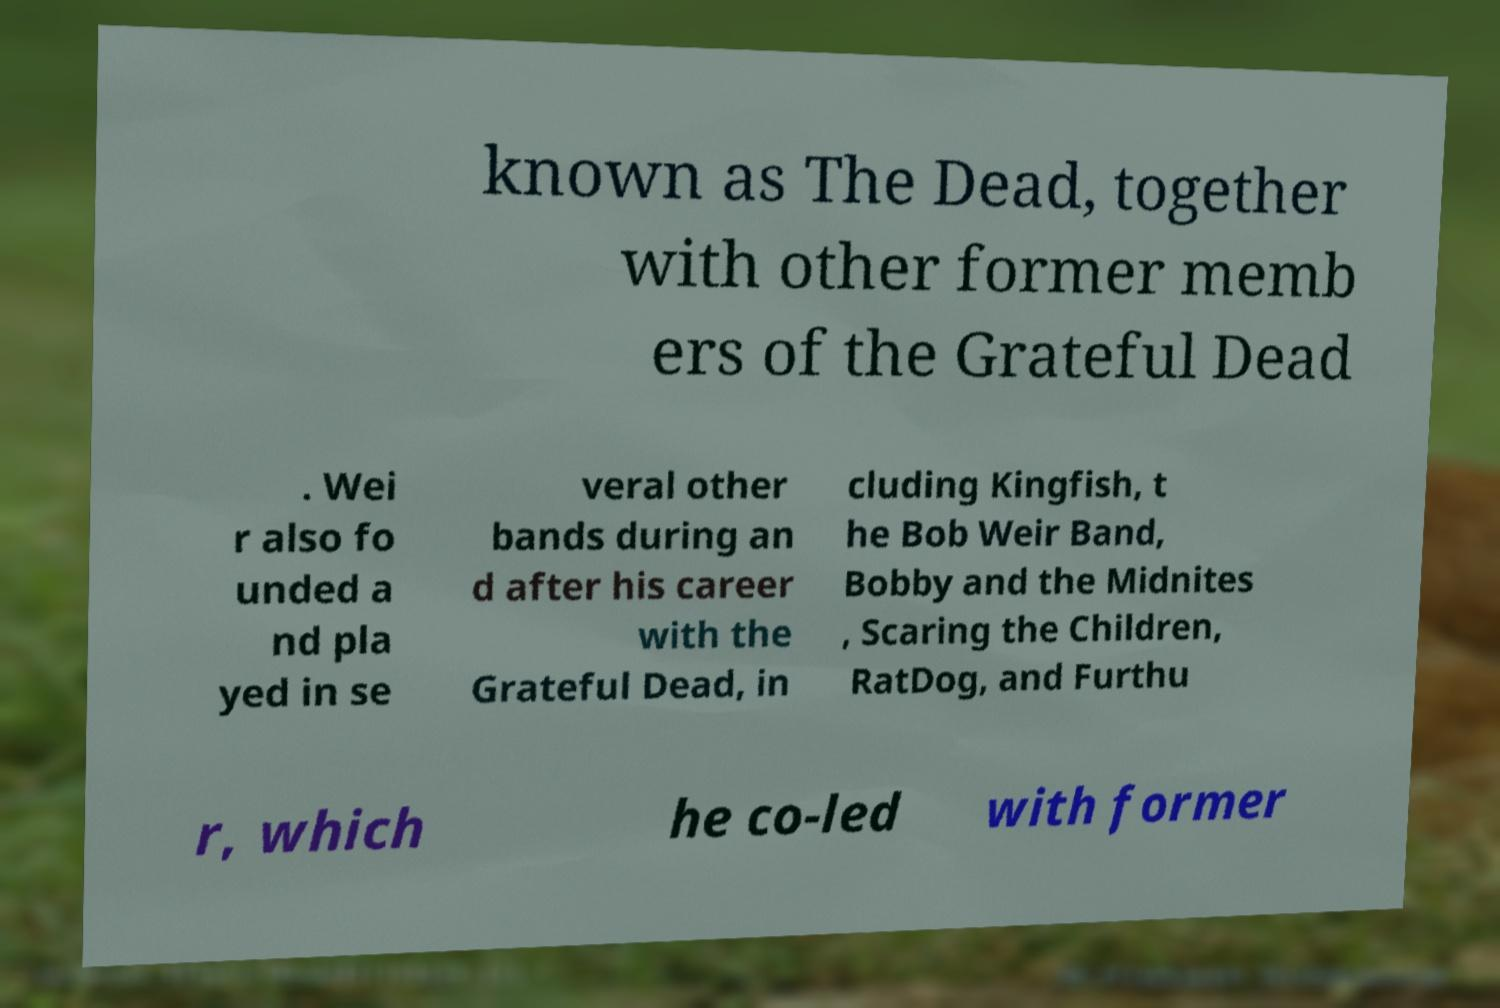There's text embedded in this image that I need extracted. Can you transcribe it verbatim? known as The Dead, together with other former memb ers of the Grateful Dead . Wei r also fo unded a nd pla yed in se veral other bands during an d after his career with the Grateful Dead, in cluding Kingfish, t he Bob Weir Band, Bobby and the Midnites , Scaring the Children, RatDog, and Furthu r, which he co-led with former 